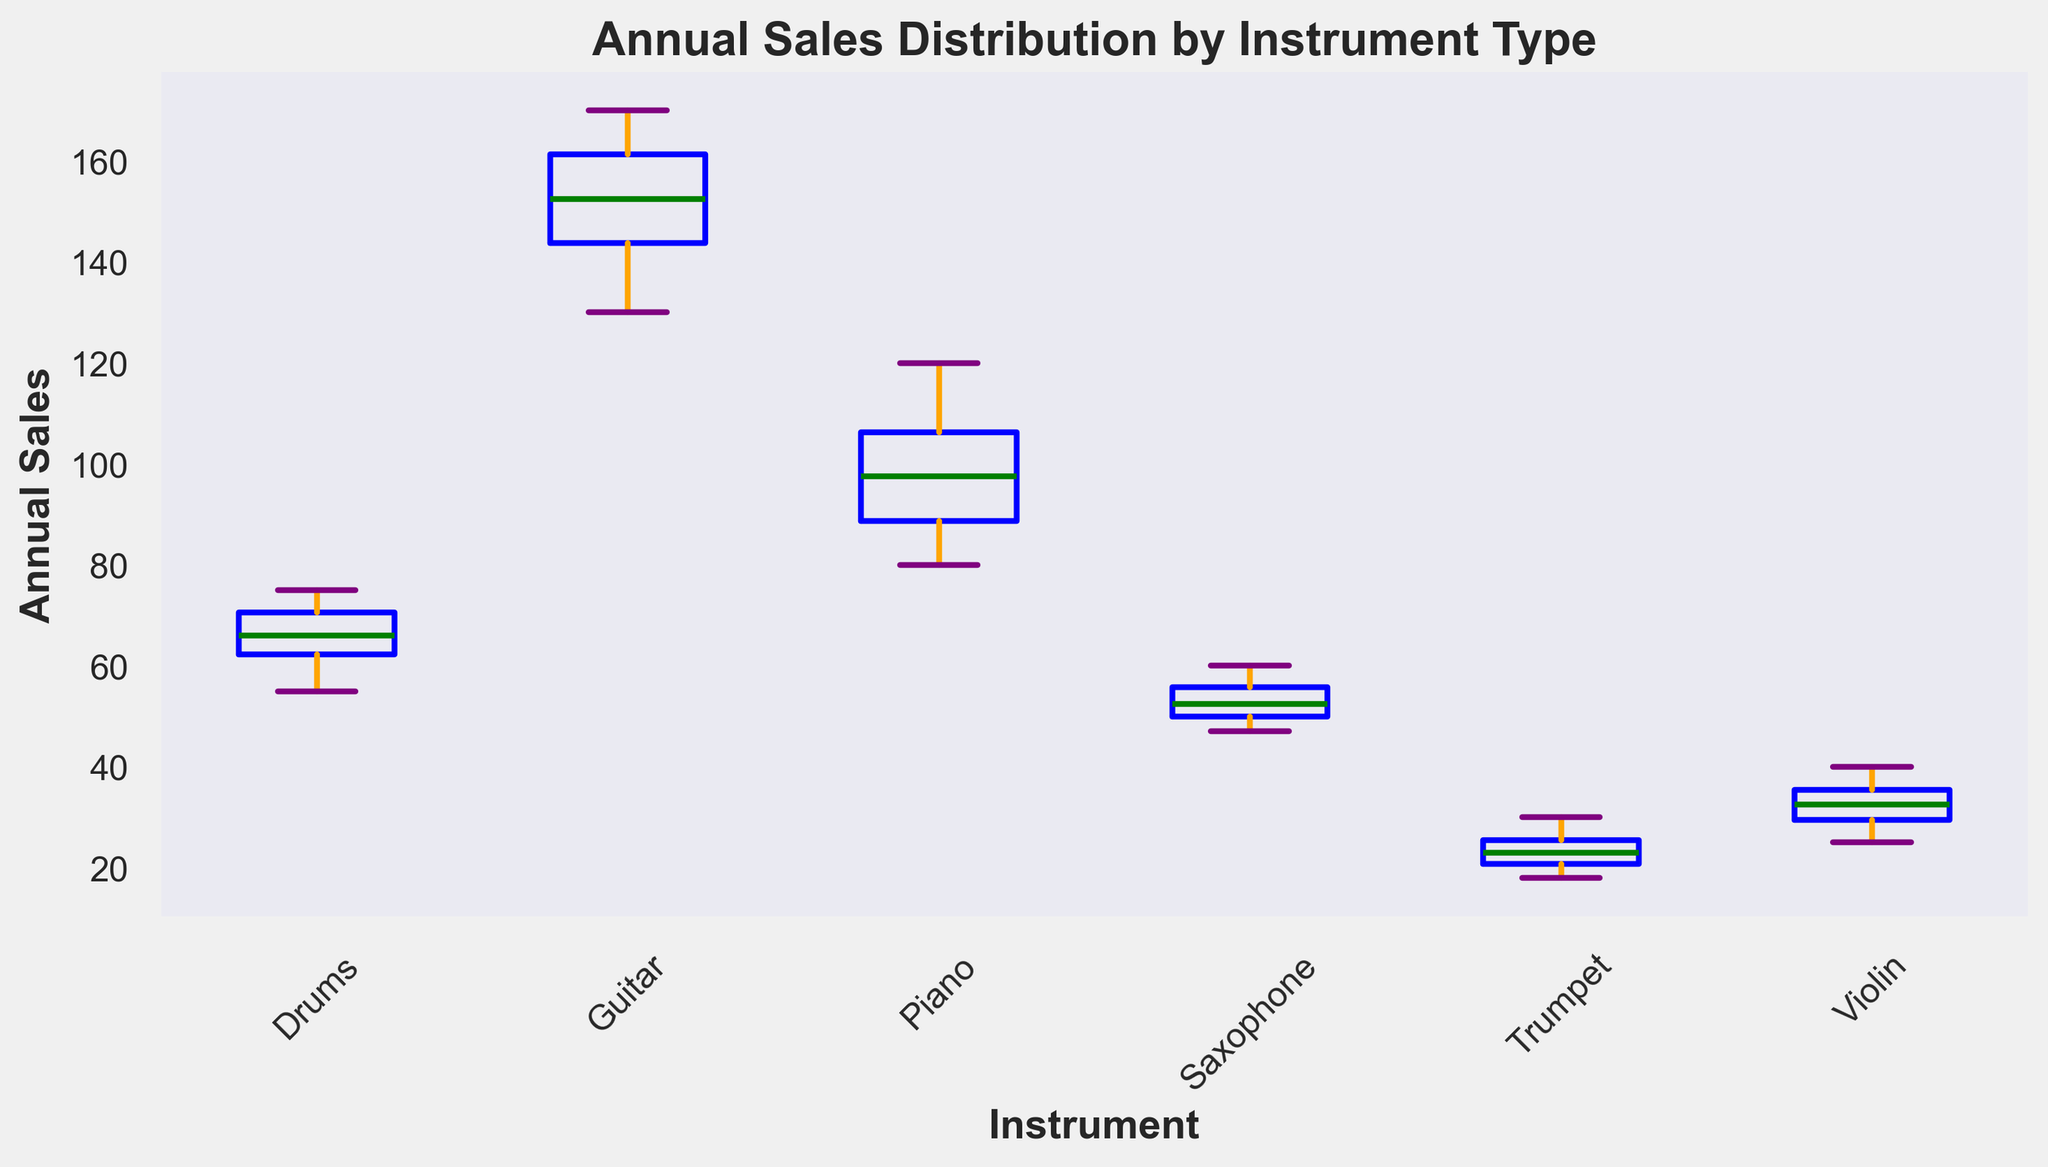What's the median annual sales for 'Piano'? To find the median, we list the annual sales values for Piano in order: 80, 85, 90, 95, 100, 105, 110, 120. The median is the middle value, so between 95 and 100. Thus, the average of 95 and 100 is 97.5.
Answer: 97.5 Which instrument type has the highest median annual sales? We compare the median annual sales for each instrument type. The figure shows that Guitar has the highest median value compared to others.
Answer: Guitar What is the interquartile range (IQR) of 'Drums'? The IQR is found by subtracting the first quartile (Q1) from the third quartile (Q3). From the plot, Q1 is 60 and Q3 is 70 for Drums, therefore IQR = 70 - 60 = 10.
Answer: 10 Which instrument has the widest range for annual sales? The range is calculated by finding the difference between the maximum and minimum values. From the box plot, Guitar has the widest range with a minimum of 130 and a maximum of 170, resulting in a range of 170 - 130 = 40.
Answer: Guitar Are there any outliers for 'Trumpet'? Outliers are indicated by points that fall outside the whiskers of the box plot. For Trumpet, there do not appear to be any such points, meaning there are no outliers.
Answer: No Which instrument's sales data has the smallest variation? Variation in sales data is indicated by the length of the box plot's range and the closeness of the whiskers. Trumpet shows the smallest variation as the whiskers and box are comparably smaller and more condensed than the others.
Answer: Trumpet If we combine the median sales of 'Violin' and 'Saxophone', what would be the result? The median sales for Violin is 32.5 and for Saxophone, it is 52. Combining these, 32.5 + 52 = 84.5.
Answer: 84.5 Which instrument's maximum annual sales is almost the same as its median annual sales? We observe both the median and maximum marks on the box plot. The violin's maximum value (40) is quite close to its median value (approximately 33).
Answer: Violin What is the highest annual sales value across all instrument types? Looking at the top-most points of the whiskers, the highest value is seen for Guitar, which has a maximum annual sale of 170.
Answer: 170 